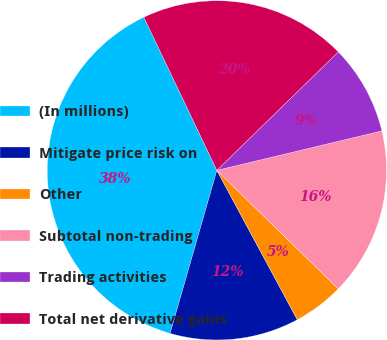Convert chart to OTSL. <chart><loc_0><loc_0><loc_500><loc_500><pie_chart><fcel>(In millions)<fcel>Mitigate price risk on<fcel>Other<fcel>Subtotal non-trading<fcel>Trading activities<fcel>Total net derivative gains<nl><fcel>38.47%<fcel>12.31%<fcel>4.83%<fcel>16.04%<fcel>8.57%<fcel>19.78%<nl></chart> 